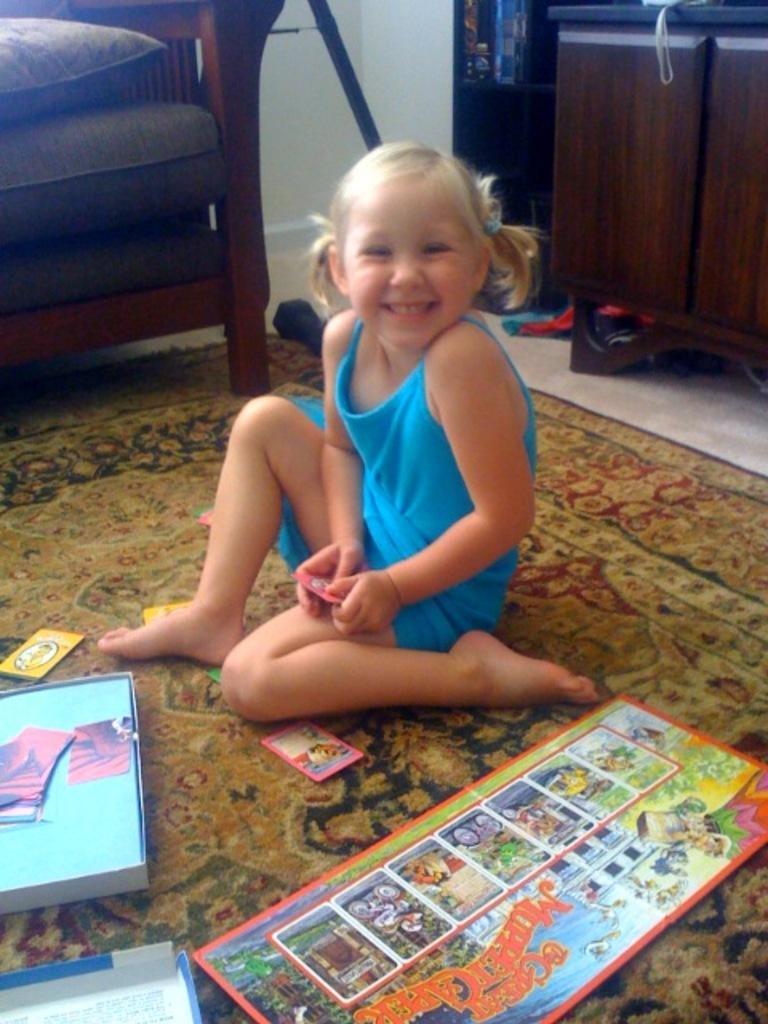Please provide a concise description of this image. In this image I can see a girl is sitting on the floor mat, she wore blue color dress. At the bottom there are books, at the top it looks like a sofa. 